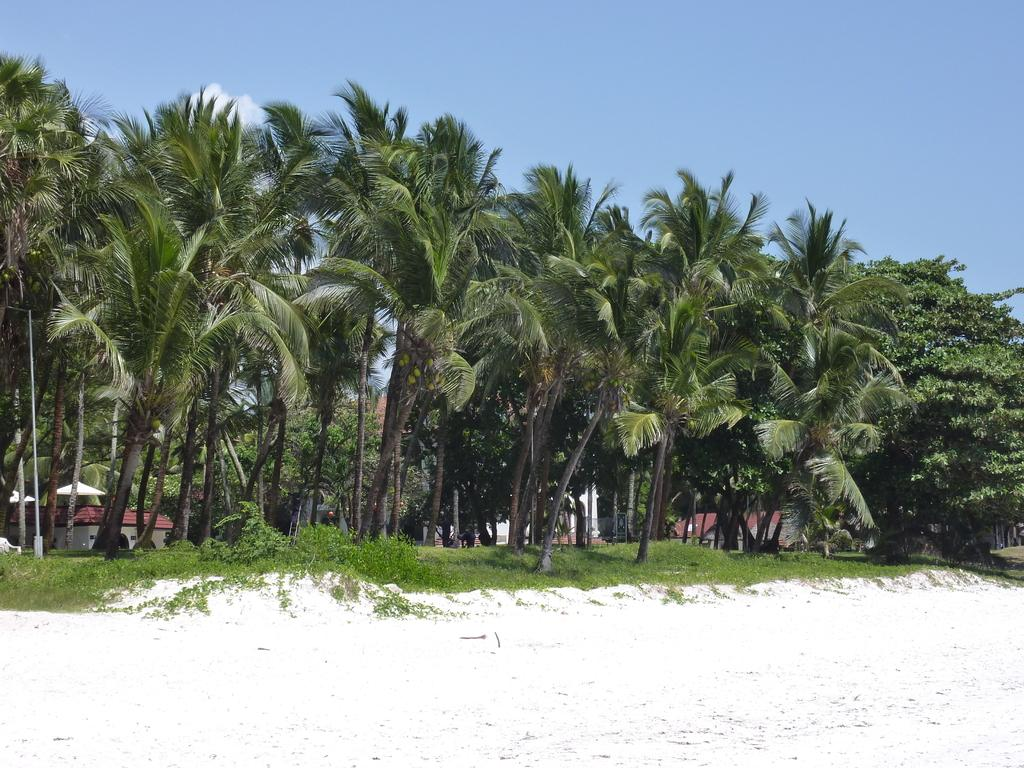What type of vegetation can be seen in the image? There are trees in the image. What type of structures are visible in the image? There are houses in the image. What part of the houses can be seen in the image? There are roofs in the image. What object is present in the image that is typically used for supporting or holding something? There is a pole in the image. What type of living organisms can be seen in the image besides trees? There are plants in the image. What type of terrain is visible at the bottom of the image? There is sand visible at the bottom of the image. What can be seen in the sky at the top of the image? There are clouds in the sky at the top of the image. What type of precipitation is falling from the clouds in the image? There is no precipitation visible in the image; only clouds are present in the sky. How many trees are resting on the roofs in the image? There are no trees resting on the roofs in the image; trees and roofs are separate entities. 